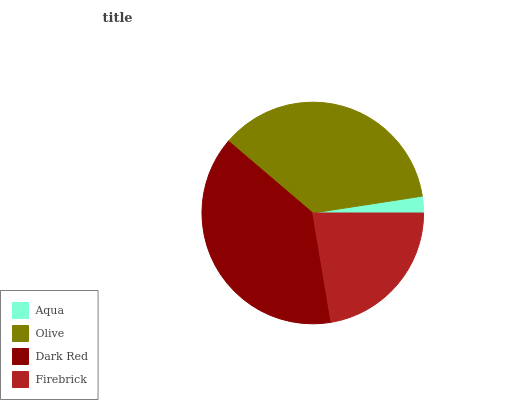Is Aqua the minimum?
Answer yes or no. Yes. Is Dark Red the maximum?
Answer yes or no. Yes. Is Olive the minimum?
Answer yes or no. No. Is Olive the maximum?
Answer yes or no. No. Is Olive greater than Aqua?
Answer yes or no. Yes. Is Aqua less than Olive?
Answer yes or no. Yes. Is Aqua greater than Olive?
Answer yes or no. No. Is Olive less than Aqua?
Answer yes or no. No. Is Olive the high median?
Answer yes or no. Yes. Is Firebrick the low median?
Answer yes or no. Yes. Is Dark Red the high median?
Answer yes or no. No. Is Olive the low median?
Answer yes or no. No. 